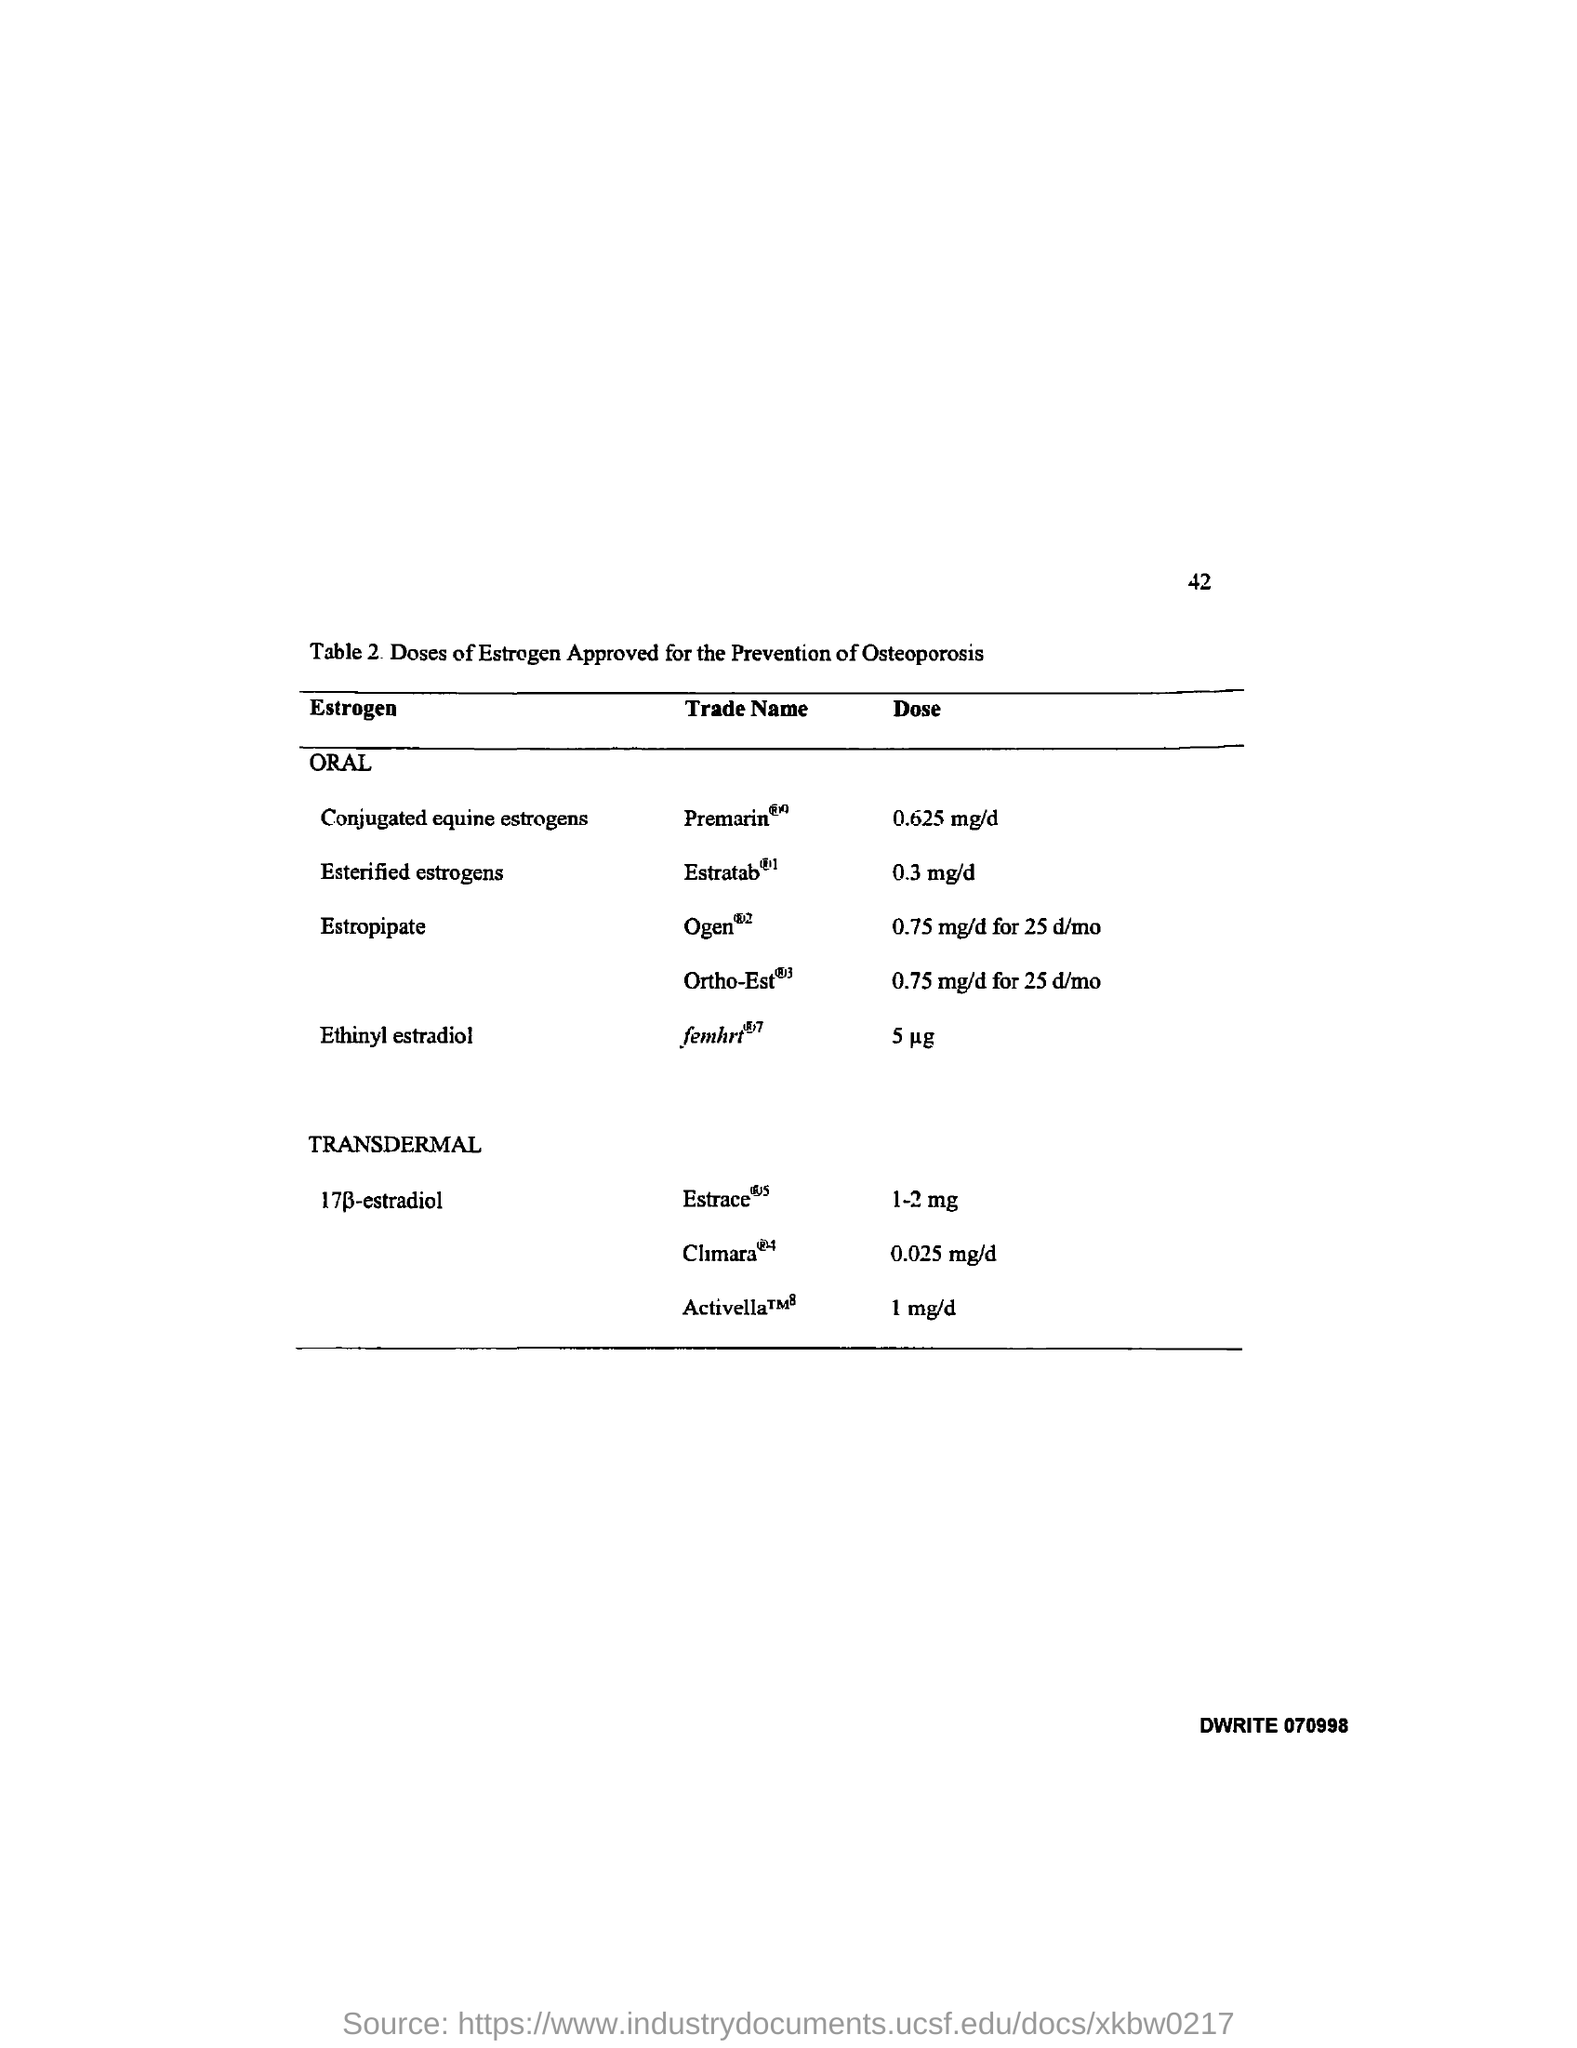What is the Page Number?
Provide a short and direct response. 42. 